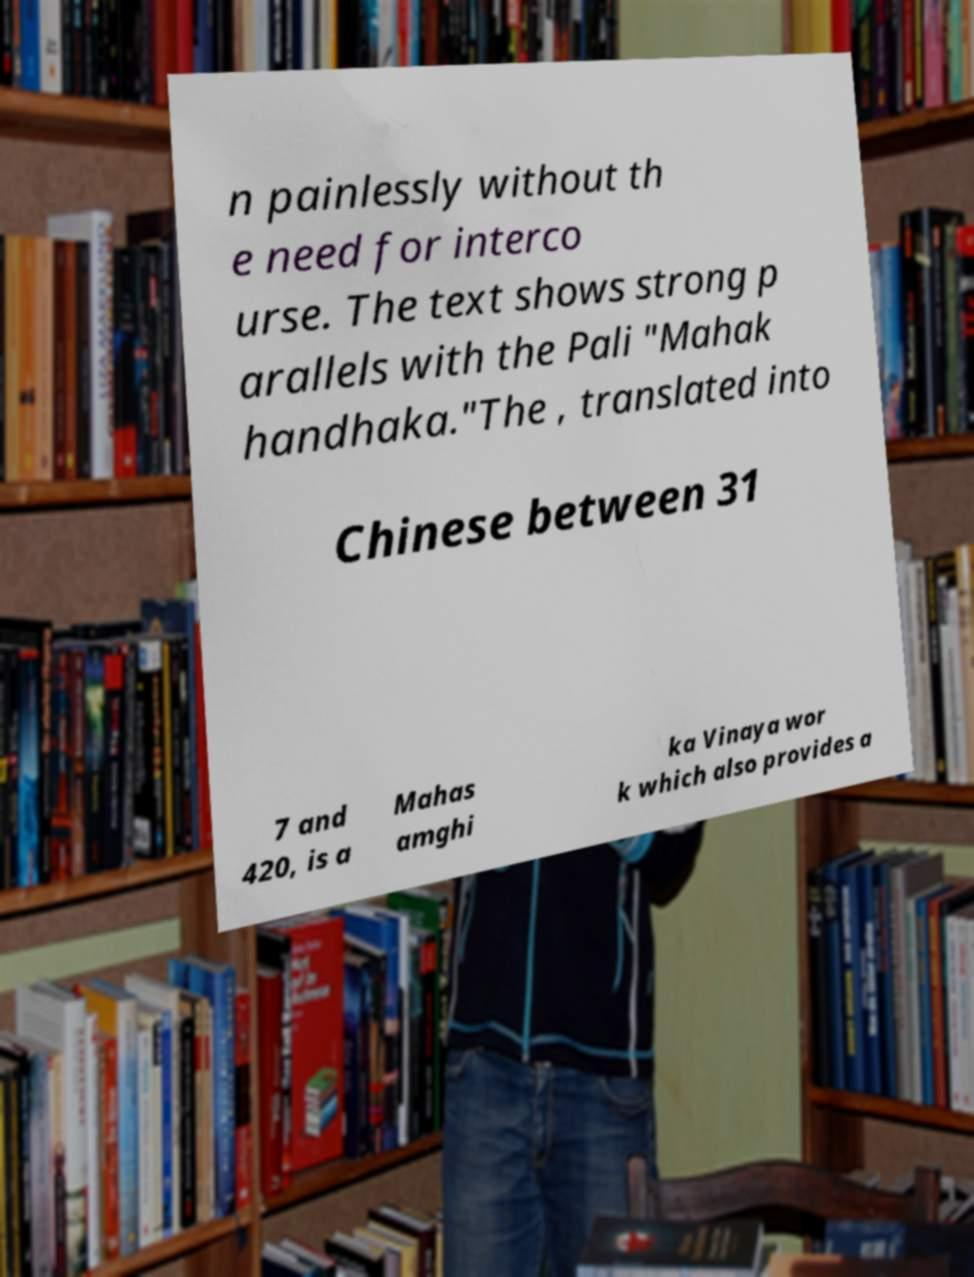I need the written content from this picture converted into text. Can you do that? n painlessly without th e need for interco urse. The text shows strong p arallels with the Pali "Mahak handhaka."The , translated into Chinese between 31 7 and 420, is a Mahas amghi ka Vinaya wor k which also provides a 